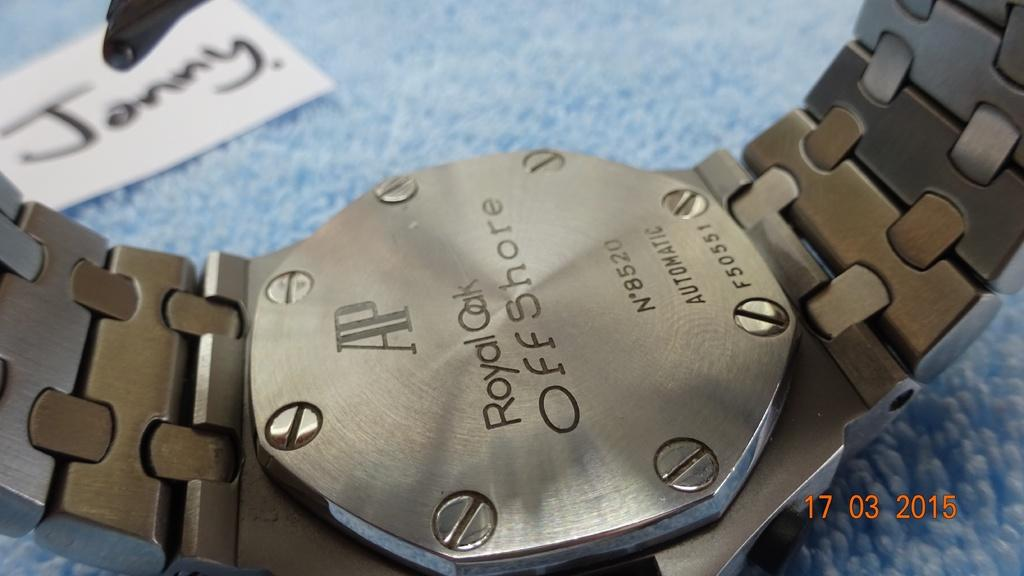<image>
Describe the image concisely. A watch with Royal Oak OffShore engraved on its back. 